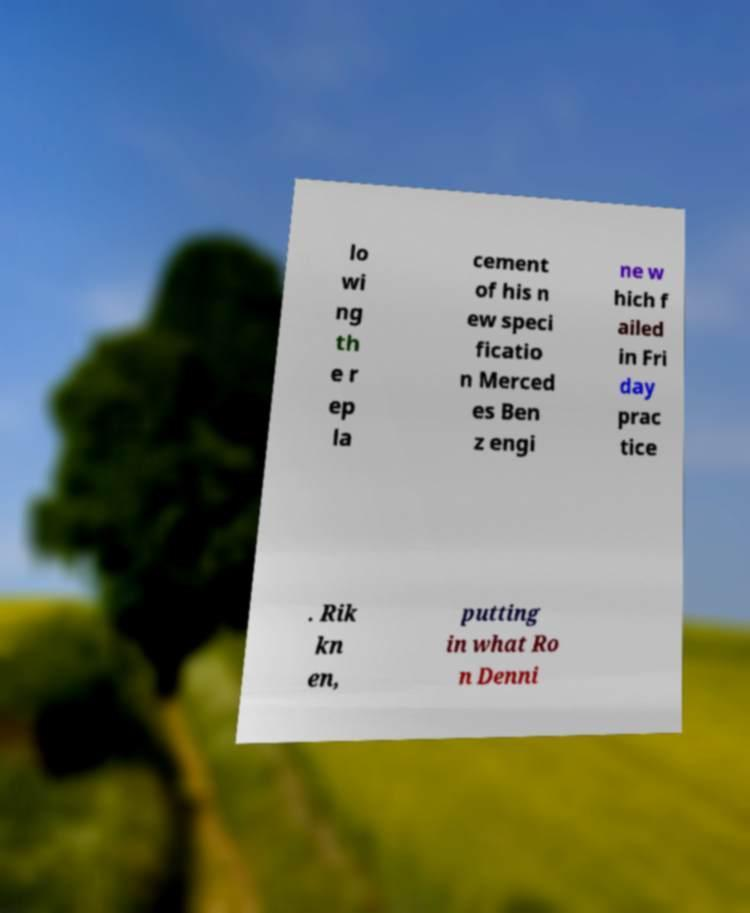Please read and relay the text visible in this image. What does it say? lo wi ng th e r ep la cement of his n ew speci ficatio n Merced es Ben z engi ne w hich f ailed in Fri day prac tice . Rik kn en, putting in what Ro n Denni 